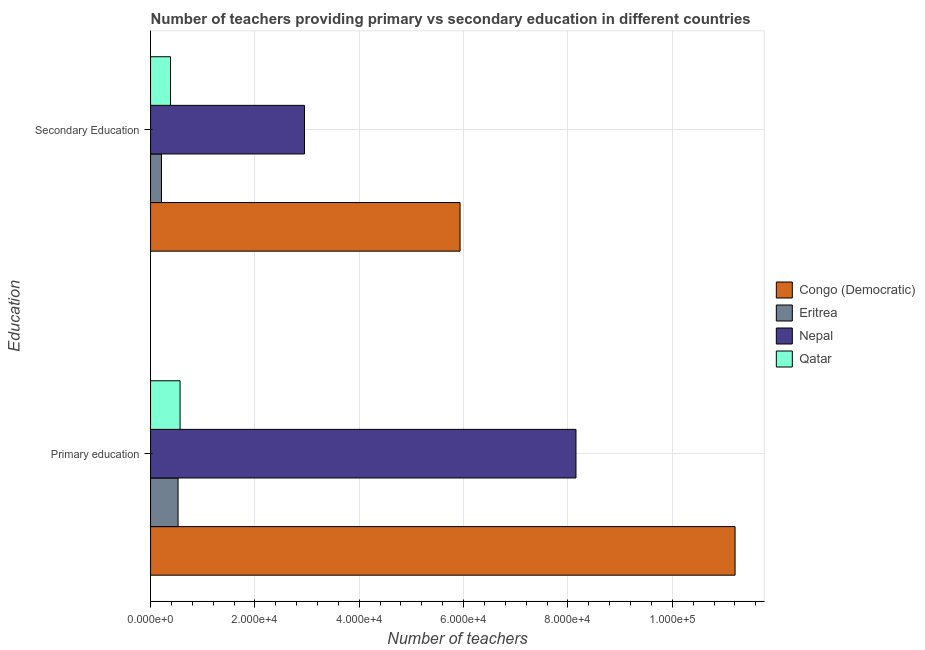How many different coloured bars are there?
Keep it short and to the point. 4. Are the number of bars on each tick of the Y-axis equal?
Make the answer very short. Yes. How many bars are there on the 2nd tick from the bottom?
Offer a terse response. 4. What is the number of primary teachers in Eritrea?
Offer a terse response. 5272. Across all countries, what is the maximum number of primary teachers?
Provide a short and direct response. 1.12e+05. Across all countries, what is the minimum number of secondary teachers?
Ensure brevity in your answer.  2095. In which country was the number of primary teachers maximum?
Your answer should be very brief. Congo (Democratic). In which country was the number of primary teachers minimum?
Your answer should be very brief. Eritrea. What is the total number of secondary teachers in the graph?
Offer a very short reply. 9.47e+04. What is the difference between the number of primary teachers in Nepal and that in Eritrea?
Provide a succinct answer. 7.63e+04. What is the difference between the number of primary teachers in Congo (Democratic) and the number of secondary teachers in Qatar?
Offer a terse response. 1.08e+05. What is the average number of secondary teachers per country?
Your answer should be compact. 2.37e+04. What is the difference between the number of secondary teachers and number of primary teachers in Eritrea?
Your answer should be very brief. -3177. What is the ratio of the number of primary teachers in Eritrea to that in Congo (Democratic)?
Provide a succinct answer. 0.05. What does the 3rd bar from the top in Primary education represents?
Give a very brief answer. Eritrea. What does the 1st bar from the bottom in Primary education represents?
Provide a succinct answer. Congo (Democratic). How many bars are there?
Ensure brevity in your answer.  8. Are all the bars in the graph horizontal?
Offer a terse response. Yes. What is the difference between two consecutive major ticks on the X-axis?
Your answer should be compact. 2.00e+04. Where does the legend appear in the graph?
Ensure brevity in your answer.  Center right. What is the title of the graph?
Your answer should be very brief. Number of teachers providing primary vs secondary education in different countries. What is the label or title of the X-axis?
Your answer should be very brief. Number of teachers. What is the label or title of the Y-axis?
Make the answer very short. Education. What is the Number of teachers in Congo (Democratic) in Primary education?
Keep it short and to the point. 1.12e+05. What is the Number of teachers in Eritrea in Primary education?
Ensure brevity in your answer.  5272. What is the Number of teachers in Nepal in Primary education?
Keep it short and to the point. 8.15e+04. What is the Number of teachers of Qatar in Primary education?
Your response must be concise. 5656. What is the Number of teachers of Congo (Democratic) in Secondary Education?
Provide a succinct answer. 5.93e+04. What is the Number of teachers in Eritrea in Secondary Education?
Provide a short and direct response. 2095. What is the Number of teachers in Nepal in Secondary Education?
Provide a succinct answer. 2.95e+04. What is the Number of teachers of Qatar in Secondary Education?
Ensure brevity in your answer.  3823. Across all Education, what is the maximum Number of teachers of Congo (Democratic)?
Your answer should be very brief. 1.12e+05. Across all Education, what is the maximum Number of teachers in Eritrea?
Ensure brevity in your answer.  5272. Across all Education, what is the maximum Number of teachers of Nepal?
Give a very brief answer. 8.15e+04. Across all Education, what is the maximum Number of teachers in Qatar?
Give a very brief answer. 5656. Across all Education, what is the minimum Number of teachers of Congo (Democratic)?
Your answer should be very brief. 5.93e+04. Across all Education, what is the minimum Number of teachers in Eritrea?
Make the answer very short. 2095. Across all Education, what is the minimum Number of teachers of Nepal?
Offer a terse response. 2.95e+04. Across all Education, what is the minimum Number of teachers of Qatar?
Your answer should be very brief. 3823. What is the total Number of teachers in Congo (Democratic) in the graph?
Your response must be concise. 1.71e+05. What is the total Number of teachers in Eritrea in the graph?
Provide a succinct answer. 7367. What is the total Number of teachers in Nepal in the graph?
Ensure brevity in your answer.  1.11e+05. What is the total Number of teachers in Qatar in the graph?
Your response must be concise. 9479. What is the difference between the Number of teachers in Congo (Democratic) in Primary education and that in Secondary Education?
Your answer should be compact. 5.27e+04. What is the difference between the Number of teachers in Eritrea in Primary education and that in Secondary Education?
Provide a succinct answer. 3177. What is the difference between the Number of teachers in Nepal in Primary education and that in Secondary Education?
Give a very brief answer. 5.20e+04. What is the difference between the Number of teachers in Qatar in Primary education and that in Secondary Education?
Your answer should be compact. 1833. What is the difference between the Number of teachers of Congo (Democratic) in Primary education and the Number of teachers of Eritrea in Secondary Education?
Provide a succinct answer. 1.10e+05. What is the difference between the Number of teachers of Congo (Democratic) in Primary education and the Number of teachers of Nepal in Secondary Education?
Give a very brief answer. 8.25e+04. What is the difference between the Number of teachers of Congo (Democratic) in Primary education and the Number of teachers of Qatar in Secondary Education?
Make the answer very short. 1.08e+05. What is the difference between the Number of teachers of Eritrea in Primary education and the Number of teachers of Nepal in Secondary Education?
Your answer should be compact. -2.42e+04. What is the difference between the Number of teachers of Eritrea in Primary education and the Number of teachers of Qatar in Secondary Education?
Your answer should be very brief. 1449. What is the difference between the Number of teachers of Nepal in Primary education and the Number of teachers of Qatar in Secondary Education?
Your response must be concise. 7.77e+04. What is the average Number of teachers of Congo (Democratic) per Education?
Your answer should be compact. 8.57e+04. What is the average Number of teachers in Eritrea per Education?
Provide a succinct answer. 3683.5. What is the average Number of teachers of Nepal per Education?
Your answer should be compact. 5.55e+04. What is the average Number of teachers of Qatar per Education?
Give a very brief answer. 4739.5. What is the difference between the Number of teachers of Congo (Democratic) and Number of teachers of Eritrea in Primary education?
Make the answer very short. 1.07e+05. What is the difference between the Number of teachers in Congo (Democratic) and Number of teachers in Nepal in Primary education?
Keep it short and to the point. 3.05e+04. What is the difference between the Number of teachers of Congo (Democratic) and Number of teachers of Qatar in Primary education?
Provide a succinct answer. 1.06e+05. What is the difference between the Number of teachers of Eritrea and Number of teachers of Nepal in Primary education?
Keep it short and to the point. -7.63e+04. What is the difference between the Number of teachers in Eritrea and Number of teachers in Qatar in Primary education?
Offer a terse response. -384. What is the difference between the Number of teachers of Nepal and Number of teachers of Qatar in Primary education?
Offer a terse response. 7.59e+04. What is the difference between the Number of teachers of Congo (Democratic) and Number of teachers of Eritrea in Secondary Education?
Offer a very short reply. 5.72e+04. What is the difference between the Number of teachers of Congo (Democratic) and Number of teachers of Nepal in Secondary Education?
Give a very brief answer. 2.98e+04. What is the difference between the Number of teachers in Congo (Democratic) and Number of teachers in Qatar in Secondary Education?
Give a very brief answer. 5.55e+04. What is the difference between the Number of teachers in Eritrea and Number of teachers in Nepal in Secondary Education?
Ensure brevity in your answer.  -2.74e+04. What is the difference between the Number of teachers in Eritrea and Number of teachers in Qatar in Secondary Education?
Give a very brief answer. -1728. What is the difference between the Number of teachers of Nepal and Number of teachers of Qatar in Secondary Education?
Provide a succinct answer. 2.57e+04. What is the ratio of the Number of teachers of Congo (Democratic) in Primary education to that in Secondary Education?
Provide a short and direct response. 1.89. What is the ratio of the Number of teachers in Eritrea in Primary education to that in Secondary Education?
Offer a very short reply. 2.52. What is the ratio of the Number of teachers in Nepal in Primary education to that in Secondary Education?
Provide a succinct answer. 2.76. What is the ratio of the Number of teachers of Qatar in Primary education to that in Secondary Education?
Provide a short and direct response. 1.48. What is the difference between the highest and the second highest Number of teachers in Congo (Democratic)?
Your answer should be compact. 5.27e+04. What is the difference between the highest and the second highest Number of teachers in Eritrea?
Keep it short and to the point. 3177. What is the difference between the highest and the second highest Number of teachers in Nepal?
Offer a terse response. 5.20e+04. What is the difference between the highest and the second highest Number of teachers of Qatar?
Offer a very short reply. 1833. What is the difference between the highest and the lowest Number of teachers in Congo (Democratic)?
Provide a short and direct response. 5.27e+04. What is the difference between the highest and the lowest Number of teachers in Eritrea?
Ensure brevity in your answer.  3177. What is the difference between the highest and the lowest Number of teachers of Nepal?
Ensure brevity in your answer.  5.20e+04. What is the difference between the highest and the lowest Number of teachers in Qatar?
Make the answer very short. 1833. 